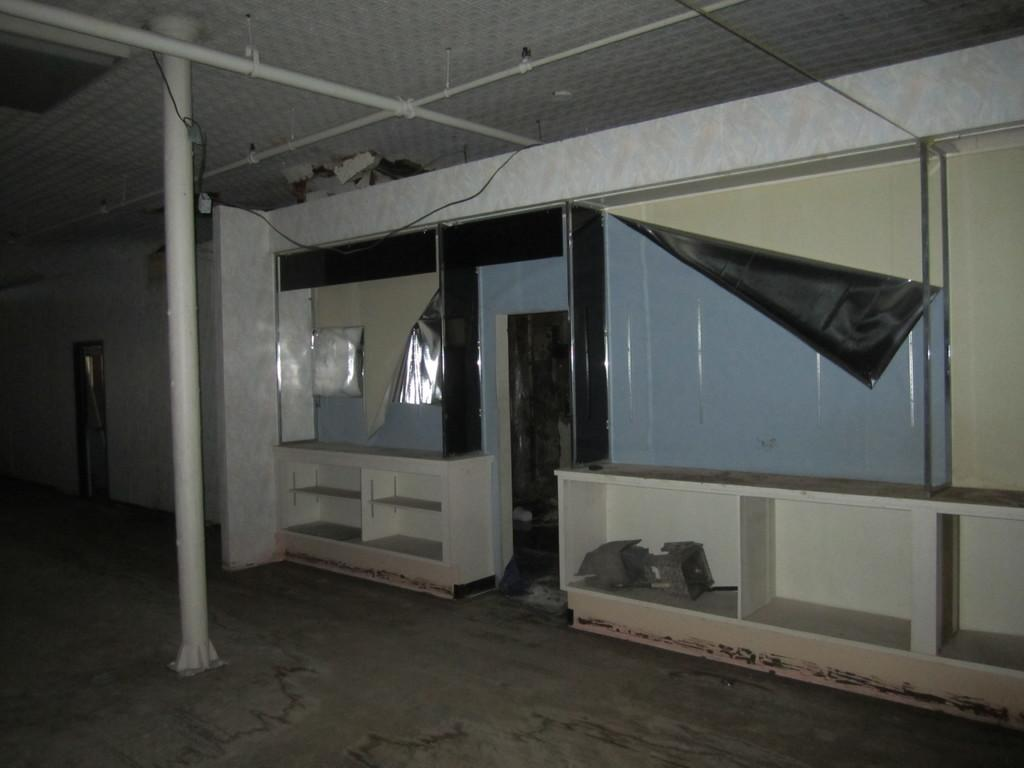What type of location is depicted in the image? The image is an inside view of a room. What can be seen on the walls of the room? There are shelves in the room. What material are the rods made of in the room? There are iron rods in the room. What other items can be found in the room besides the shelves and iron rods? There are other items in the room. What type of meal is being prepared on the queen's throne in the image? There is no queen or meal preparation present in the image; it is an inside view of a room with shelves and iron rods. 